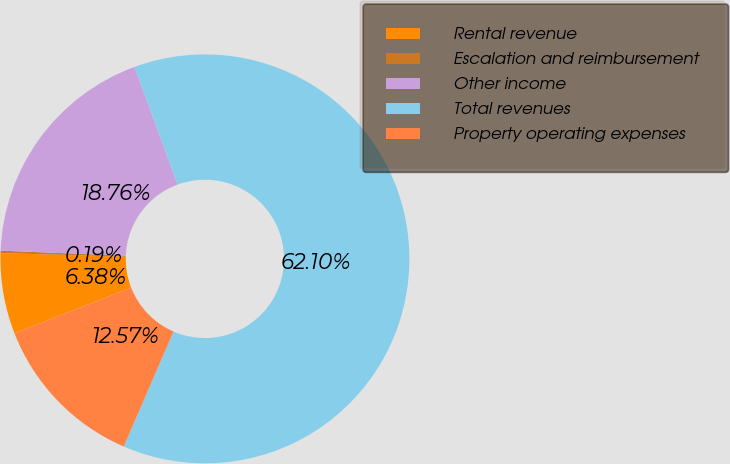Convert chart. <chart><loc_0><loc_0><loc_500><loc_500><pie_chart><fcel>Rental revenue<fcel>Escalation and reimbursement<fcel>Other income<fcel>Total revenues<fcel>Property operating expenses<nl><fcel>6.38%<fcel>0.19%<fcel>18.76%<fcel>62.09%<fcel>12.57%<nl></chart> 